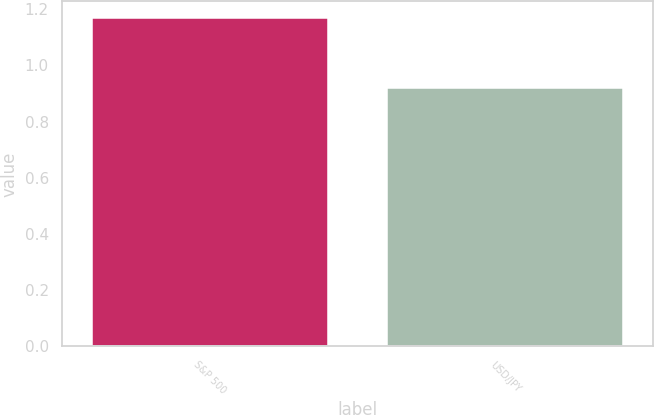Convert chart. <chart><loc_0><loc_0><loc_500><loc_500><bar_chart><fcel>S&P 500<fcel>USD/JPY<nl><fcel>1.17<fcel>0.92<nl></chart> 